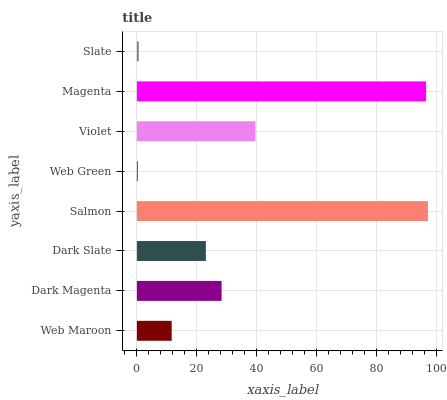Is Web Green the minimum?
Answer yes or no. Yes. Is Salmon the maximum?
Answer yes or no. Yes. Is Dark Magenta the minimum?
Answer yes or no. No. Is Dark Magenta the maximum?
Answer yes or no. No. Is Dark Magenta greater than Web Maroon?
Answer yes or no. Yes. Is Web Maroon less than Dark Magenta?
Answer yes or no. Yes. Is Web Maroon greater than Dark Magenta?
Answer yes or no. No. Is Dark Magenta less than Web Maroon?
Answer yes or no. No. Is Dark Magenta the high median?
Answer yes or no. Yes. Is Dark Slate the low median?
Answer yes or no. Yes. Is Violet the high median?
Answer yes or no. No. Is Magenta the low median?
Answer yes or no. No. 